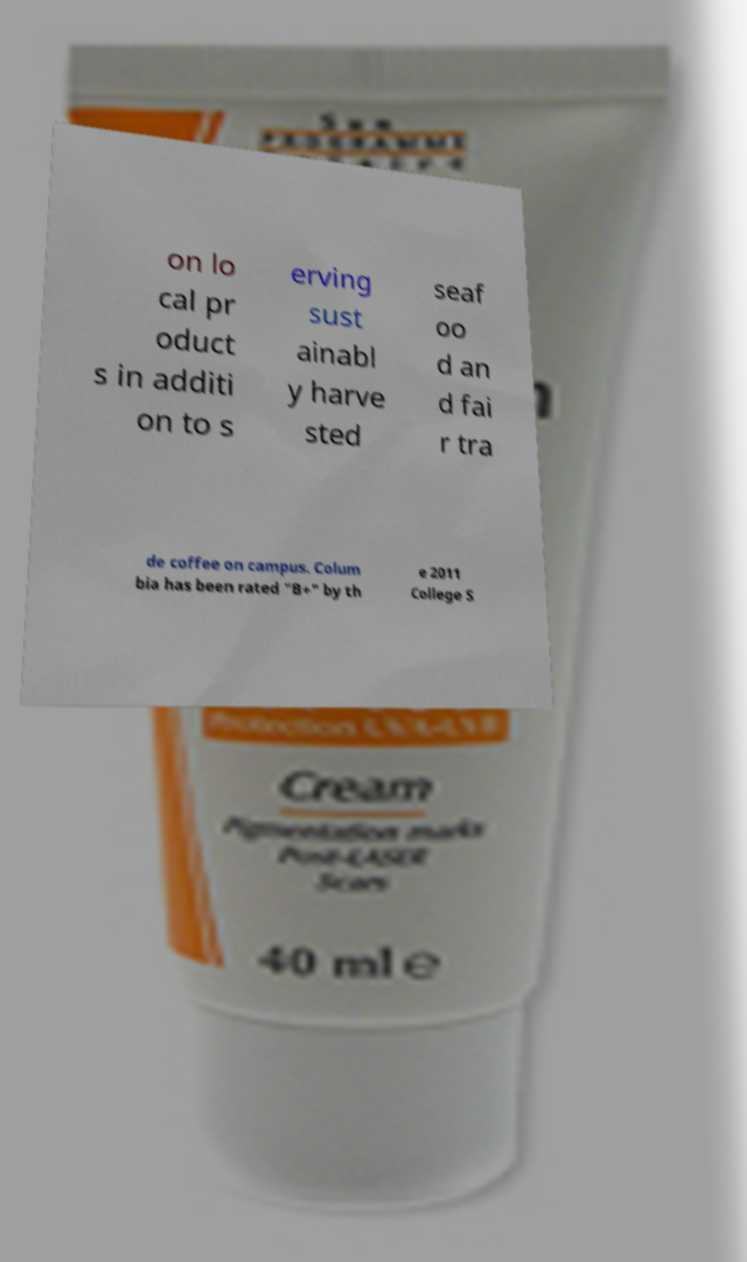Could you extract and type out the text from this image? on lo cal pr oduct s in additi on to s erving sust ainabl y harve sted seaf oo d an d fai r tra de coffee on campus. Colum bia has been rated "B+" by th e 2011 College S 